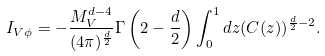<formula> <loc_0><loc_0><loc_500><loc_500>I _ { V \phi } = - \frac { M _ { V } ^ { d - 4 } } { ( 4 \pi ) ^ { \frac { d } { 2 } } } \Gamma \left ( 2 - \frac { d } { 2 } \right ) \int _ { 0 } ^ { 1 } d z ( C ( z ) ) ^ { \frac { d } { 2 } - 2 } .</formula> 